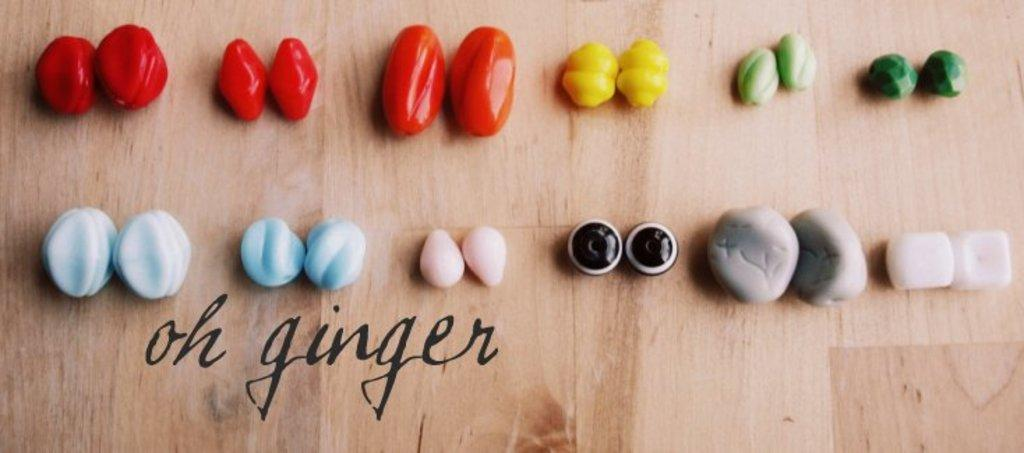What type of objects are in the image? There are colorful stone-like objects made of plastic in the image. How many colors are the objects available in? The objects are in different colors. What is the surface on which the objects are placed? The objects are on a wooden table. Is there any text present in the image? Yes, there is text at the bottom of the image. Can you tell me how the sister is helping in the image? There is no sister present in the image, nor is there any indication of someone helping. 